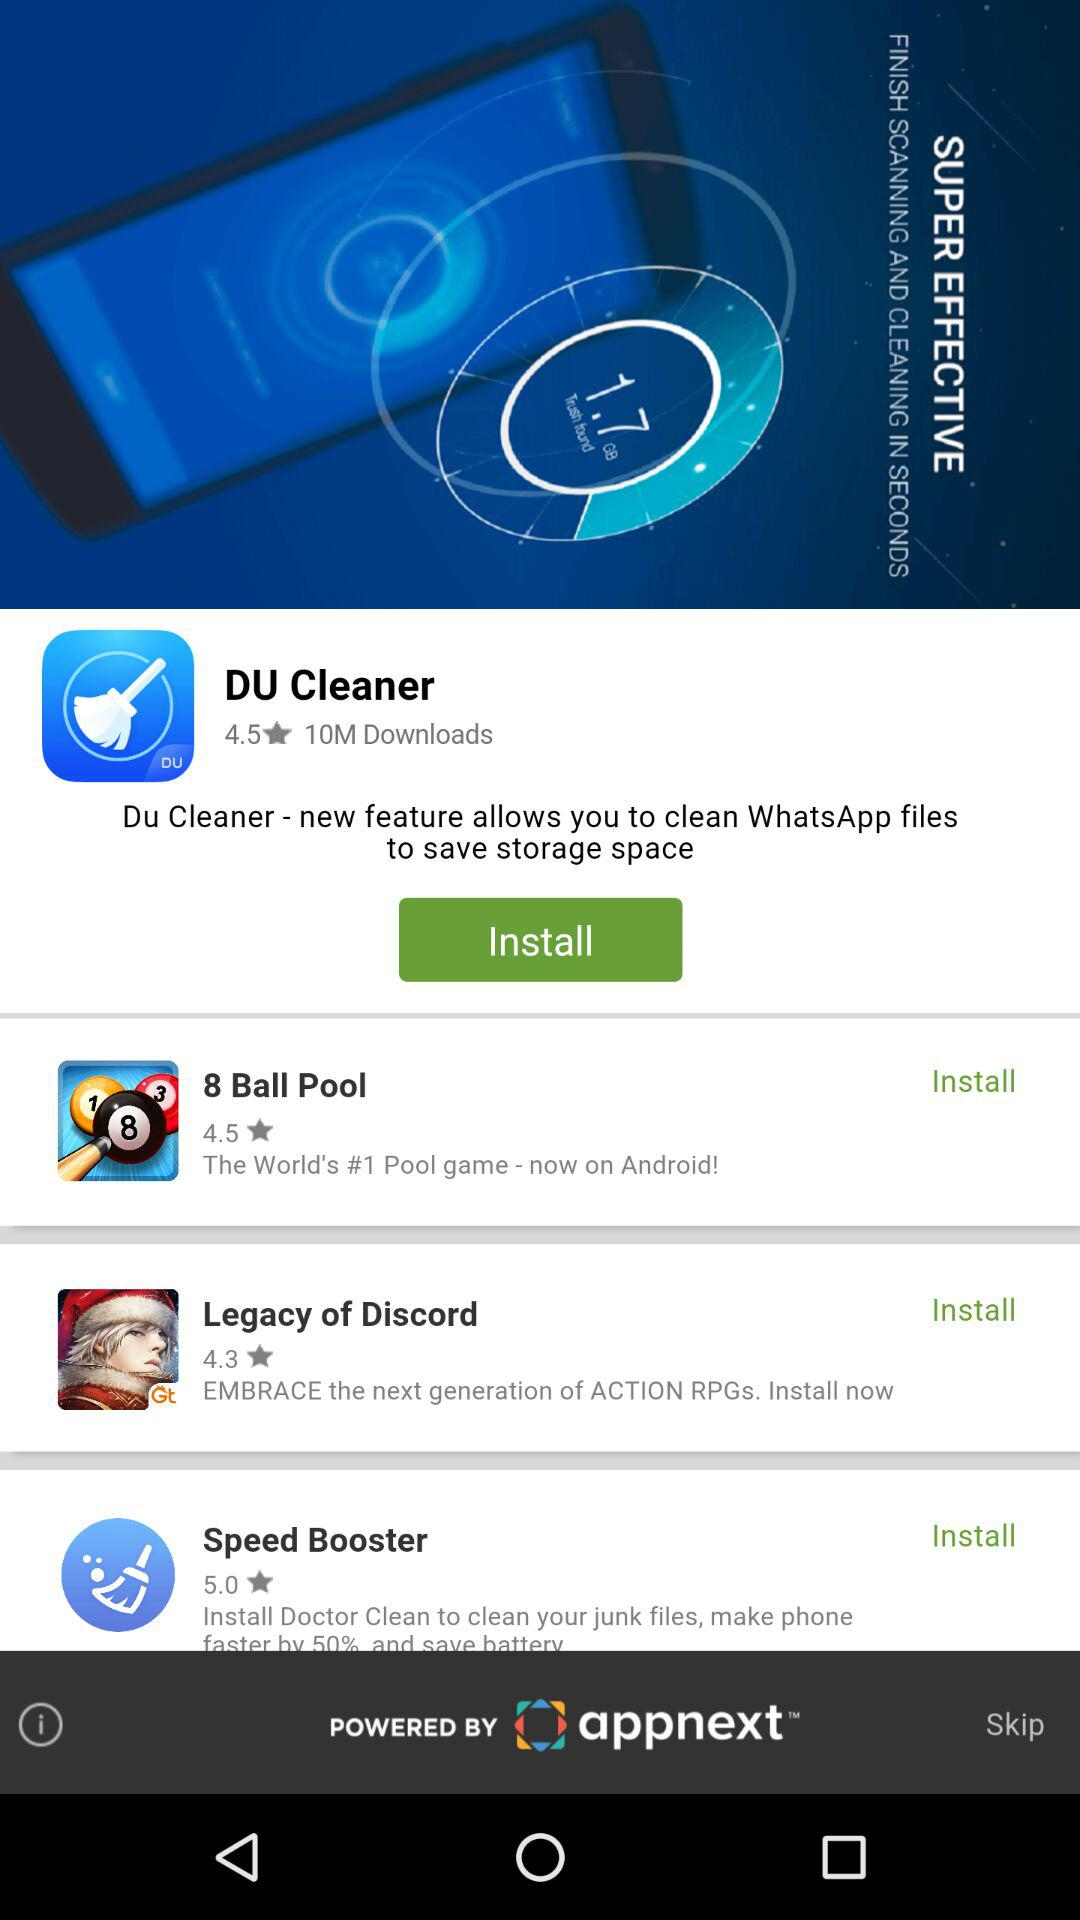What is the world's number one pool game? The world's number one pool game is "8 Ball Pool". 